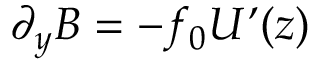Convert formula to latex. <formula><loc_0><loc_0><loc_500><loc_500>\partial _ { y } B = - f _ { 0 } U ( z )</formula> 